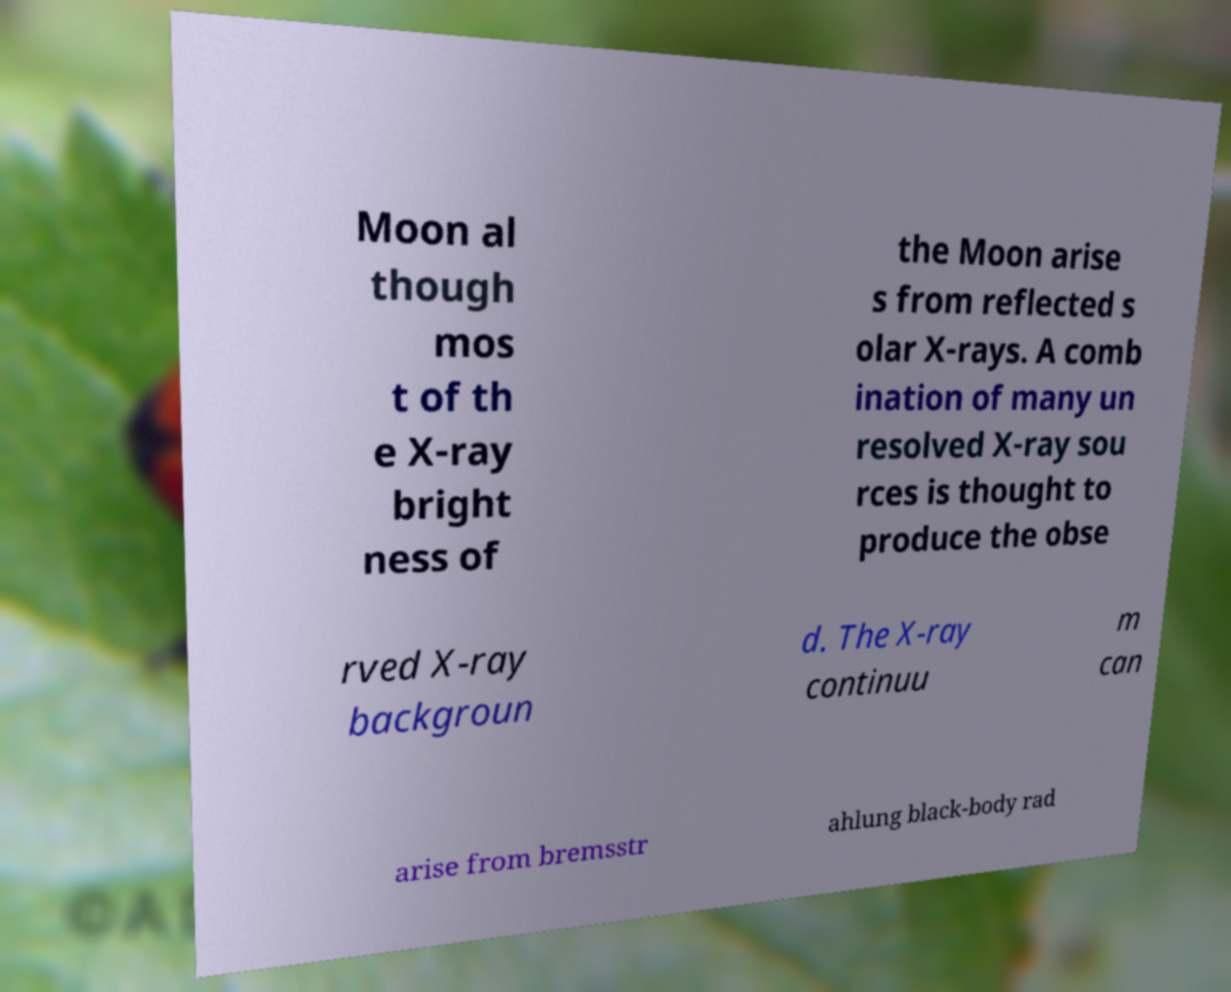Could you extract and type out the text from this image? Moon al though mos t of th e X-ray bright ness of the Moon arise s from reflected s olar X-rays. A comb ination of many un resolved X-ray sou rces is thought to produce the obse rved X-ray backgroun d. The X-ray continuu m can arise from bremsstr ahlung black-body rad 